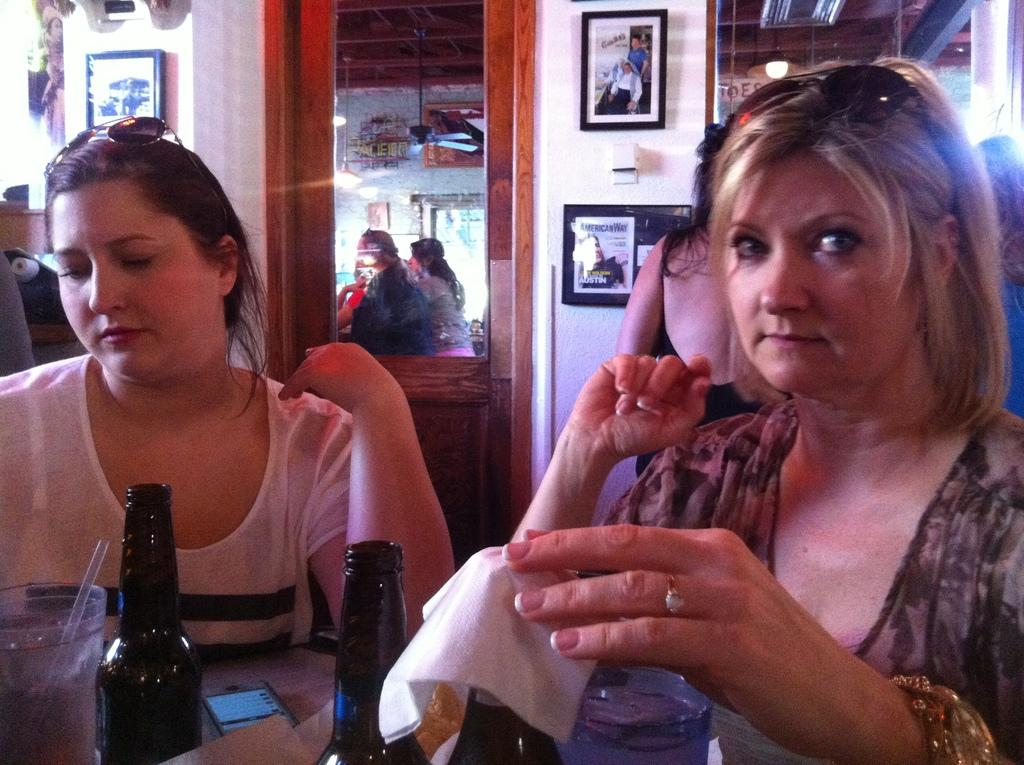What is the color of the wall in the image? The wall in the image is white. What is hung on the wall? There are frames on the wall. What type of reflective surface is in the image? There is a mirror in the image. How many people are visible in the image? Two people are sitting in the front of the image. What piece of furniture is present in the image? There is a table in the image. What electronic device is on the table? A mobile phone is present on the table. What type of beverage container is on the table? There are bottles on the table. What type of drinking vessel is on the table? There is a glass on the table. What type of road can be seen in the image? There is no road present in the image. Who is the creator of the frames on the wall? The provided facts do not mention the creator of the frames on the wall. 